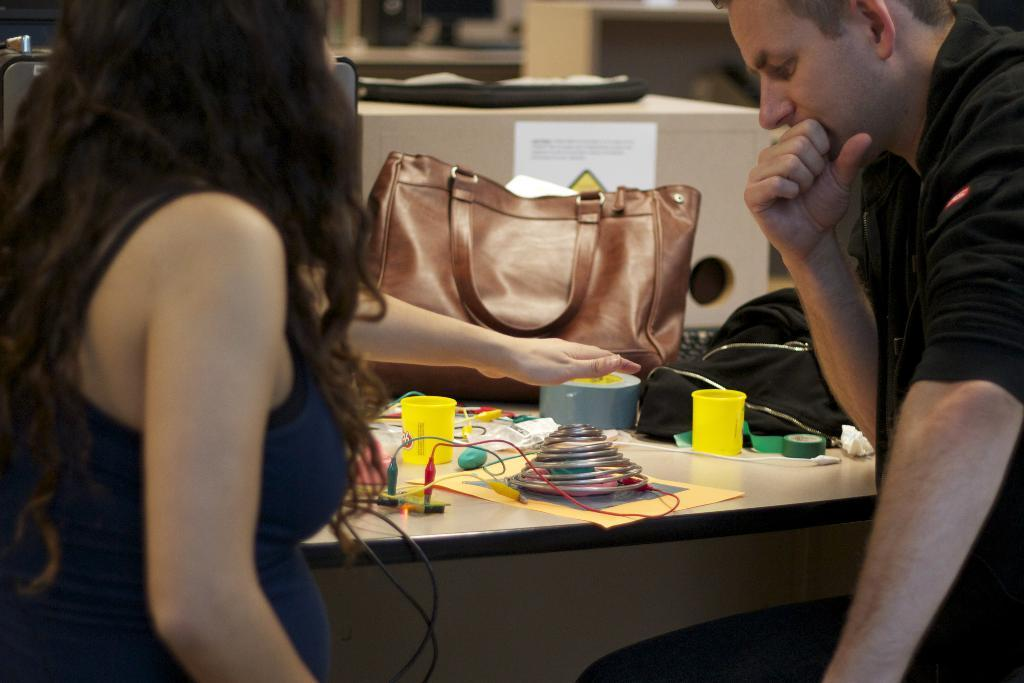What objects are on the table in the image? There are cups, a bag, and unspecified "things" on the table in the image. How many standing persons are in the image? There are two standing persons in the image. What is on the cupboard in the image? There is a poster on the cupboard in the image. What type of beef is being served on the table in the image? There is no beef present in the image; the table contains cups, a bag, and unspecified "things." How many bananas are on the table in the image? There are no bananas present in the image; the table contains cups, a bag, and unspecified "things." 